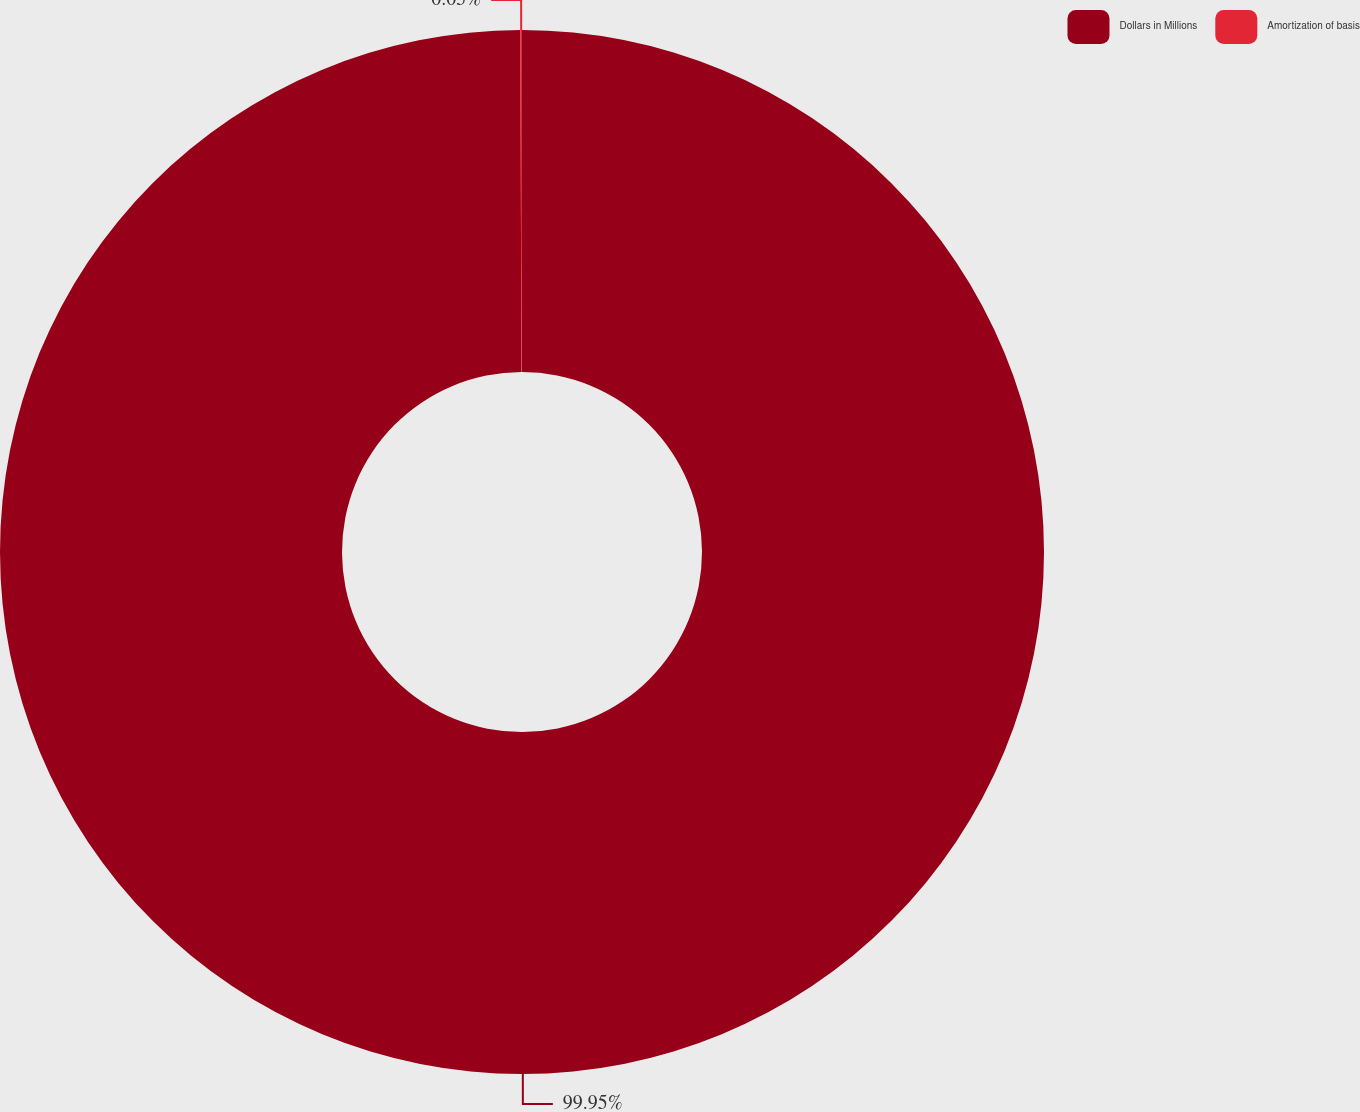Convert chart to OTSL. <chart><loc_0><loc_0><loc_500><loc_500><pie_chart><fcel>Dollars in Millions<fcel>Amortization of basis<nl><fcel>99.95%<fcel>0.05%<nl></chart> 